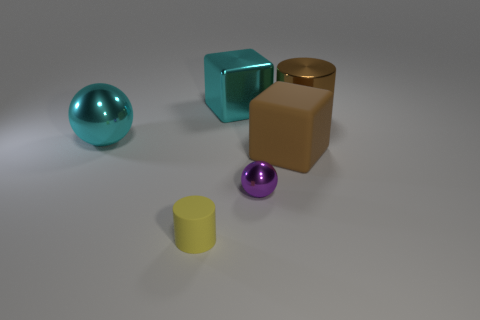How many big shiny cylinders have the same color as the large matte block?
Provide a succinct answer. 1. What is the color of the large cylinder that is made of the same material as the tiny purple object?
Your answer should be very brief. Brown. Is there another yellow matte thing that has the same size as the yellow matte thing?
Keep it short and to the point. No. Are there more metallic cubes in front of the large brown metal cylinder than large rubber blocks behind the tiny yellow cylinder?
Your answer should be very brief. No. Are the ball to the right of the yellow thing and the cylinder in front of the brown shiny object made of the same material?
Provide a short and direct response. No. What shape is the brown rubber thing that is the same size as the brown cylinder?
Your response must be concise. Cube. Are there any tiny yellow matte things that have the same shape as the brown rubber object?
Offer a very short reply. No. There is a big cube that is in front of the large sphere; is its color the same as the metal ball that is on the left side of the purple ball?
Provide a short and direct response. No. Are there any cyan shiny things behind the large brown shiny object?
Your answer should be very brief. Yes. There is a large thing that is on the right side of the rubber cylinder and on the left side of the purple metallic sphere; what material is it?
Give a very brief answer. Metal. 